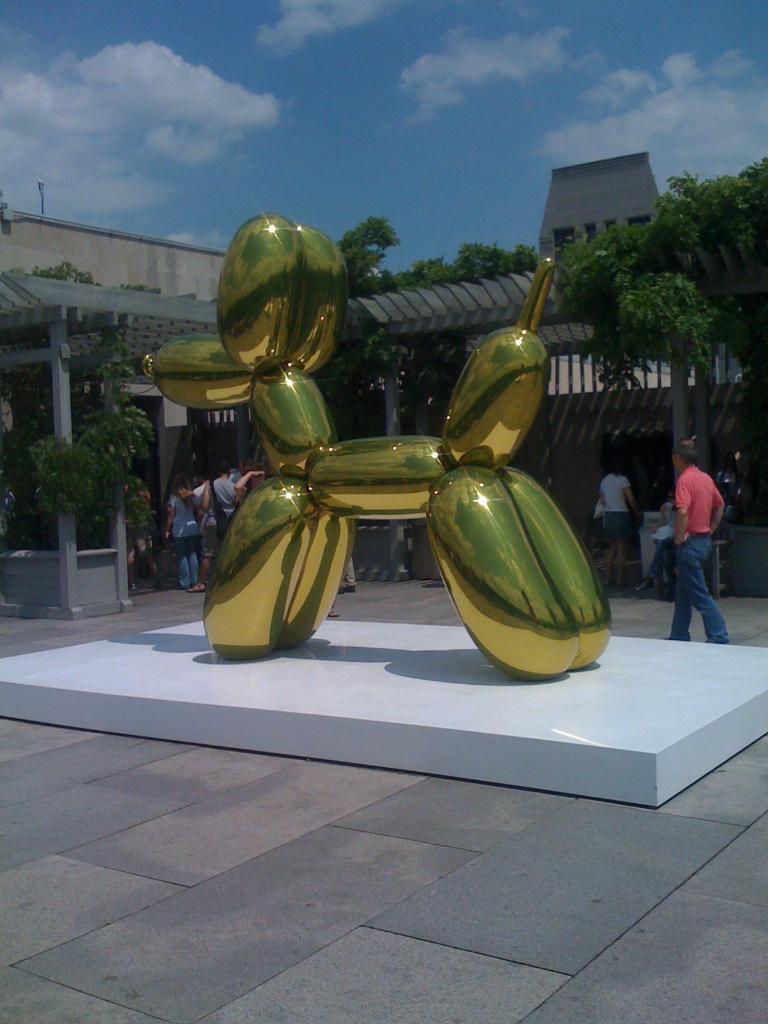Could you give a brief overview of what you see in this image? In this image there is a structure of a dog, behind that there are a few people standing and walking on the road. In the background there is a building, trees and a sky. 